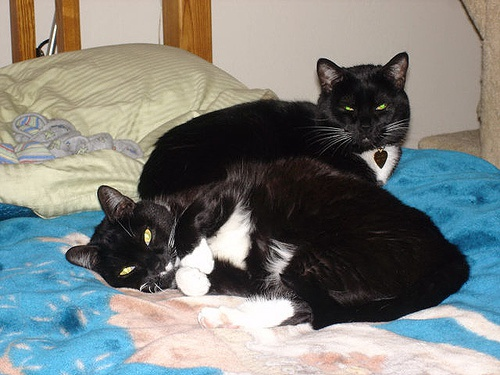Describe the objects in this image and their specific colors. I can see bed in darkgray, lightgray, tan, and lightblue tones, cat in darkgray, black, white, and gray tones, and cat in darkgray, black, and gray tones in this image. 